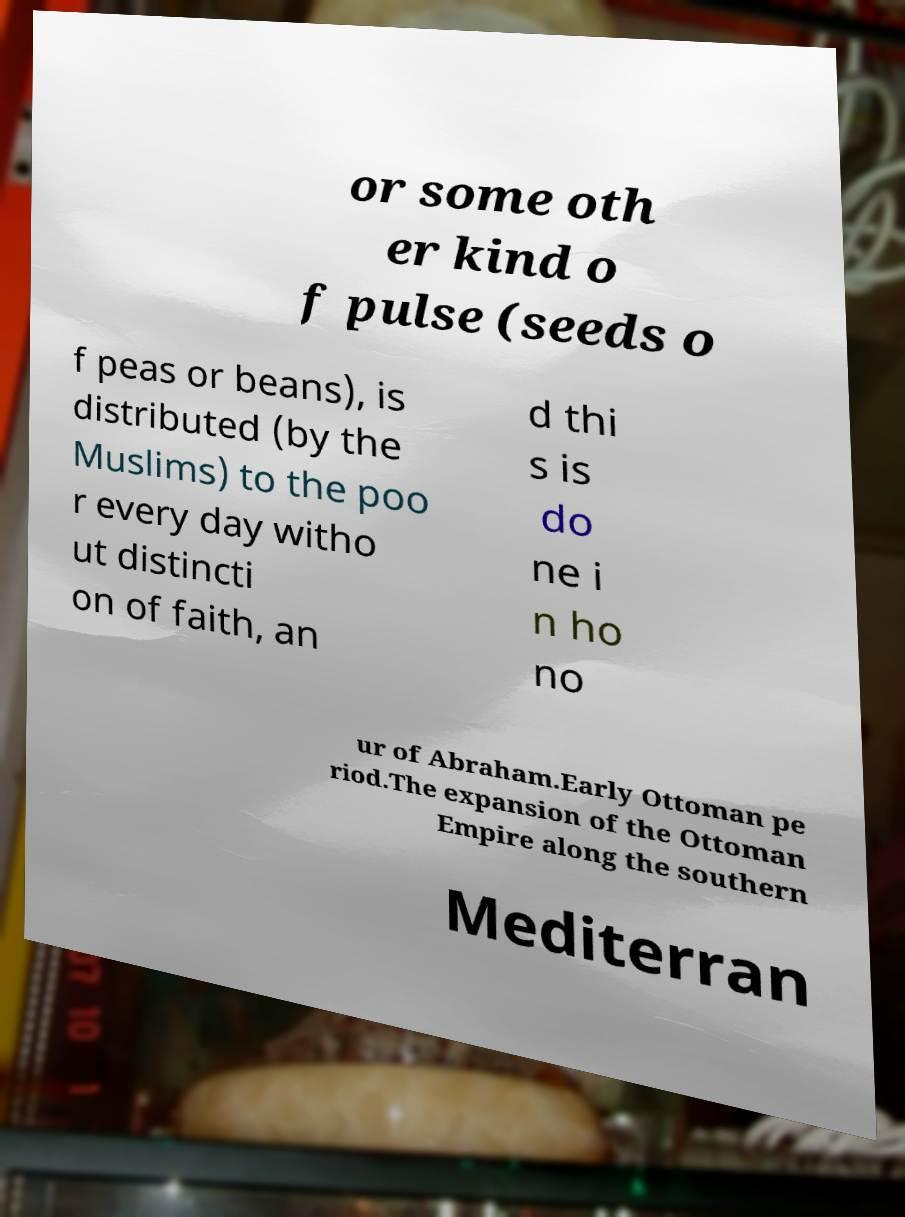Could you assist in decoding the text presented in this image and type it out clearly? or some oth er kind o f pulse (seeds o f peas or beans), is distributed (by the Muslims) to the poo r every day witho ut distincti on of faith, an d thi s is do ne i n ho no ur of Abraham.Early Ottoman pe riod.The expansion of the Ottoman Empire along the southern Mediterran 